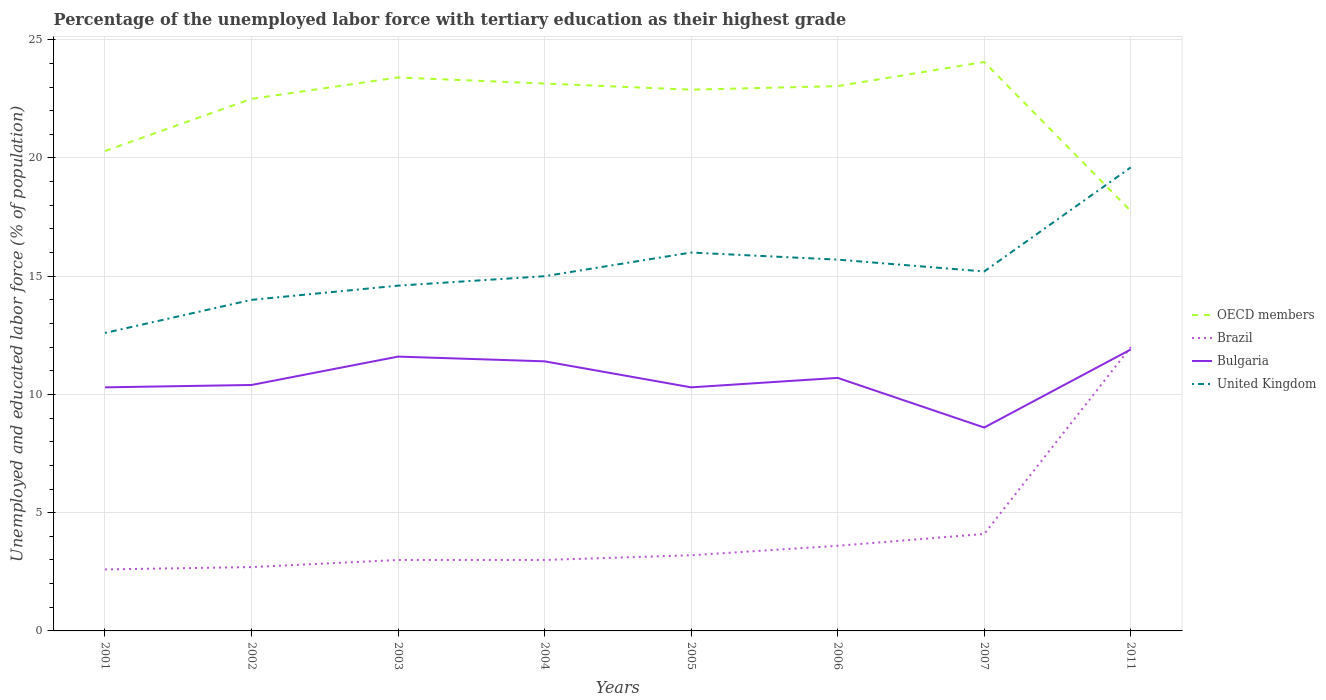How many different coloured lines are there?
Provide a succinct answer. 4. Does the line corresponding to United Kingdom intersect with the line corresponding to Brazil?
Your answer should be very brief. No. Is the number of lines equal to the number of legend labels?
Ensure brevity in your answer.  Yes. Across all years, what is the maximum percentage of the unemployed labor force with tertiary education in United Kingdom?
Your answer should be very brief. 12.6. In which year was the percentage of the unemployed labor force with tertiary education in Bulgaria maximum?
Give a very brief answer. 2007. What is the total percentage of the unemployed labor force with tertiary education in United Kingdom in the graph?
Make the answer very short. -3.4. What is the difference between the highest and the second highest percentage of the unemployed labor force with tertiary education in Brazil?
Offer a very short reply. 9.4. What is the difference between the highest and the lowest percentage of the unemployed labor force with tertiary education in Bulgaria?
Offer a terse response. 4. Does the graph contain any zero values?
Provide a succinct answer. No. Does the graph contain grids?
Provide a short and direct response. Yes. Where does the legend appear in the graph?
Ensure brevity in your answer.  Center right. How many legend labels are there?
Provide a short and direct response. 4. What is the title of the graph?
Provide a short and direct response. Percentage of the unemployed labor force with tertiary education as their highest grade. What is the label or title of the Y-axis?
Make the answer very short. Unemployed and educated labor force (% of population). What is the Unemployed and educated labor force (% of population) of OECD members in 2001?
Your answer should be very brief. 20.29. What is the Unemployed and educated labor force (% of population) in Brazil in 2001?
Provide a succinct answer. 2.6. What is the Unemployed and educated labor force (% of population) in Bulgaria in 2001?
Offer a very short reply. 10.3. What is the Unemployed and educated labor force (% of population) of United Kingdom in 2001?
Your answer should be compact. 12.6. What is the Unemployed and educated labor force (% of population) of OECD members in 2002?
Your response must be concise. 22.5. What is the Unemployed and educated labor force (% of population) in Brazil in 2002?
Offer a terse response. 2.7. What is the Unemployed and educated labor force (% of population) of Bulgaria in 2002?
Offer a very short reply. 10.4. What is the Unemployed and educated labor force (% of population) of OECD members in 2003?
Offer a very short reply. 23.4. What is the Unemployed and educated labor force (% of population) in Brazil in 2003?
Keep it short and to the point. 3. What is the Unemployed and educated labor force (% of population) of Bulgaria in 2003?
Provide a succinct answer. 11.6. What is the Unemployed and educated labor force (% of population) in United Kingdom in 2003?
Your response must be concise. 14.6. What is the Unemployed and educated labor force (% of population) of OECD members in 2004?
Keep it short and to the point. 23.15. What is the Unemployed and educated labor force (% of population) of Brazil in 2004?
Offer a terse response. 3. What is the Unemployed and educated labor force (% of population) in Bulgaria in 2004?
Provide a short and direct response. 11.4. What is the Unemployed and educated labor force (% of population) of OECD members in 2005?
Your answer should be very brief. 22.89. What is the Unemployed and educated labor force (% of population) in Brazil in 2005?
Ensure brevity in your answer.  3.2. What is the Unemployed and educated labor force (% of population) of Bulgaria in 2005?
Give a very brief answer. 10.3. What is the Unemployed and educated labor force (% of population) in United Kingdom in 2005?
Offer a very short reply. 16. What is the Unemployed and educated labor force (% of population) in OECD members in 2006?
Offer a very short reply. 23.04. What is the Unemployed and educated labor force (% of population) of Brazil in 2006?
Your answer should be very brief. 3.6. What is the Unemployed and educated labor force (% of population) of Bulgaria in 2006?
Provide a succinct answer. 10.7. What is the Unemployed and educated labor force (% of population) of United Kingdom in 2006?
Provide a short and direct response. 15.7. What is the Unemployed and educated labor force (% of population) in OECD members in 2007?
Give a very brief answer. 24.06. What is the Unemployed and educated labor force (% of population) in Brazil in 2007?
Your response must be concise. 4.1. What is the Unemployed and educated labor force (% of population) of Bulgaria in 2007?
Ensure brevity in your answer.  8.6. What is the Unemployed and educated labor force (% of population) of United Kingdom in 2007?
Offer a very short reply. 15.2. What is the Unemployed and educated labor force (% of population) in OECD members in 2011?
Provide a short and direct response. 17.76. What is the Unemployed and educated labor force (% of population) of Bulgaria in 2011?
Give a very brief answer. 11.9. What is the Unemployed and educated labor force (% of population) of United Kingdom in 2011?
Keep it short and to the point. 19.6. Across all years, what is the maximum Unemployed and educated labor force (% of population) in OECD members?
Offer a very short reply. 24.06. Across all years, what is the maximum Unemployed and educated labor force (% of population) of Brazil?
Keep it short and to the point. 12. Across all years, what is the maximum Unemployed and educated labor force (% of population) in Bulgaria?
Make the answer very short. 11.9. Across all years, what is the maximum Unemployed and educated labor force (% of population) in United Kingdom?
Your answer should be very brief. 19.6. Across all years, what is the minimum Unemployed and educated labor force (% of population) in OECD members?
Give a very brief answer. 17.76. Across all years, what is the minimum Unemployed and educated labor force (% of population) in Brazil?
Your answer should be compact. 2.6. Across all years, what is the minimum Unemployed and educated labor force (% of population) in Bulgaria?
Offer a very short reply. 8.6. Across all years, what is the minimum Unemployed and educated labor force (% of population) of United Kingdom?
Your answer should be very brief. 12.6. What is the total Unemployed and educated labor force (% of population) in OECD members in the graph?
Keep it short and to the point. 177.09. What is the total Unemployed and educated labor force (% of population) of Brazil in the graph?
Offer a terse response. 34.2. What is the total Unemployed and educated labor force (% of population) in Bulgaria in the graph?
Provide a succinct answer. 85.2. What is the total Unemployed and educated labor force (% of population) in United Kingdom in the graph?
Your answer should be compact. 122.7. What is the difference between the Unemployed and educated labor force (% of population) of OECD members in 2001 and that in 2002?
Offer a terse response. -2.2. What is the difference between the Unemployed and educated labor force (% of population) in Brazil in 2001 and that in 2002?
Make the answer very short. -0.1. What is the difference between the Unemployed and educated labor force (% of population) of OECD members in 2001 and that in 2003?
Your response must be concise. -3.11. What is the difference between the Unemployed and educated labor force (% of population) in Bulgaria in 2001 and that in 2003?
Ensure brevity in your answer.  -1.3. What is the difference between the Unemployed and educated labor force (% of population) in United Kingdom in 2001 and that in 2003?
Ensure brevity in your answer.  -2. What is the difference between the Unemployed and educated labor force (% of population) of OECD members in 2001 and that in 2004?
Provide a short and direct response. -2.85. What is the difference between the Unemployed and educated labor force (% of population) of Brazil in 2001 and that in 2004?
Give a very brief answer. -0.4. What is the difference between the Unemployed and educated labor force (% of population) of Bulgaria in 2001 and that in 2004?
Ensure brevity in your answer.  -1.1. What is the difference between the Unemployed and educated labor force (% of population) in United Kingdom in 2001 and that in 2004?
Make the answer very short. -2.4. What is the difference between the Unemployed and educated labor force (% of population) of OECD members in 2001 and that in 2005?
Your answer should be compact. -2.59. What is the difference between the Unemployed and educated labor force (% of population) of United Kingdom in 2001 and that in 2005?
Your answer should be compact. -3.4. What is the difference between the Unemployed and educated labor force (% of population) of OECD members in 2001 and that in 2006?
Ensure brevity in your answer.  -2.74. What is the difference between the Unemployed and educated labor force (% of population) of Brazil in 2001 and that in 2006?
Provide a short and direct response. -1. What is the difference between the Unemployed and educated labor force (% of population) of OECD members in 2001 and that in 2007?
Give a very brief answer. -3.77. What is the difference between the Unemployed and educated labor force (% of population) of Bulgaria in 2001 and that in 2007?
Provide a succinct answer. 1.7. What is the difference between the Unemployed and educated labor force (% of population) of OECD members in 2001 and that in 2011?
Provide a succinct answer. 2.54. What is the difference between the Unemployed and educated labor force (% of population) of Brazil in 2001 and that in 2011?
Give a very brief answer. -9.4. What is the difference between the Unemployed and educated labor force (% of population) of Bulgaria in 2001 and that in 2011?
Ensure brevity in your answer.  -1.6. What is the difference between the Unemployed and educated labor force (% of population) of United Kingdom in 2001 and that in 2011?
Offer a terse response. -7. What is the difference between the Unemployed and educated labor force (% of population) of OECD members in 2002 and that in 2003?
Keep it short and to the point. -0.91. What is the difference between the Unemployed and educated labor force (% of population) of Bulgaria in 2002 and that in 2003?
Give a very brief answer. -1.2. What is the difference between the Unemployed and educated labor force (% of population) of OECD members in 2002 and that in 2004?
Your answer should be very brief. -0.65. What is the difference between the Unemployed and educated labor force (% of population) of Brazil in 2002 and that in 2004?
Keep it short and to the point. -0.3. What is the difference between the Unemployed and educated labor force (% of population) in Bulgaria in 2002 and that in 2004?
Your answer should be very brief. -1. What is the difference between the Unemployed and educated labor force (% of population) in OECD members in 2002 and that in 2005?
Keep it short and to the point. -0.39. What is the difference between the Unemployed and educated labor force (% of population) in Brazil in 2002 and that in 2005?
Your response must be concise. -0.5. What is the difference between the Unemployed and educated labor force (% of population) in Bulgaria in 2002 and that in 2005?
Offer a terse response. 0.1. What is the difference between the Unemployed and educated labor force (% of population) in United Kingdom in 2002 and that in 2005?
Your answer should be compact. -2. What is the difference between the Unemployed and educated labor force (% of population) of OECD members in 2002 and that in 2006?
Ensure brevity in your answer.  -0.54. What is the difference between the Unemployed and educated labor force (% of population) in Bulgaria in 2002 and that in 2006?
Your response must be concise. -0.3. What is the difference between the Unemployed and educated labor force (% of population) in OECD members in 2002 and that in 2007?
Offer a very short reply. -1.56. What is the difference between the Unemployed and educated labor force (% of population) of Brazil in 2002 and that in 2007?
Your response must be concise. -1.4. What is the difference between the Unemployed and educated labor force (% of population) in United Kingdom in 2002 and that in 2007?
Give a very brief answer. -1.2. What is the difference between the Unemployed and educated labor force (% of population) in OECD members in 2002 and that in 2011?
Keep it short and to the point. 4.74. What is the difference between the Unemployed and educated labor force (% of population) in Bulgaria in 2002 and that in 2011?
Your response must be concise. -1.5. What is the difference between the Unemployed and educated labor force (% of population) in OECD members in 2003 and that in 2004?
Your answer should be compact. 0.26. What is the difference between the Unemployed and educated labor force (% of population) of Brazil in 2003 and that in 2004?
Keep it short and to the point. 0. What is the difference between the Unemployed and educated labor force (% of population) in Bulgaria in 2003 and that in 2004?
Ensure brevity in your answer.  0.2. What is the difference between the Unemployed and educated labor force (% of population) in OECD members in 2003 and that in 2005?
Your answer should be compact. 0.52. What is the difference between the Unemployed and educated labor force (% of population) in OECD members in 2003 and that in 2006?
Keep it short and to the point. 0.37. What is the difference between the Unemployed and educated labor force (% of population) of Brazil in 2003 and that in 2006?
Make the answer very short. -0.6. What is the difference between the Unemployed and educated labor force (% of population) in Bulgaria in 2003 and that in 2006?
Your answer should be very brief. 0.9. What is the difference between the Unemployed and educated labor force (% of population) in OECD members in 2003 and that in 2007?
Keep it short and to the point. -0.66. What is the difference between the Unemployed and educated labor force (% of population) of Brazil in 2003 and that in 2007?
Ensure brevity in your answer.  -1.1. What is the difference between the Unemployed and educated labor force (% of population) of United Kingdom in 2003 and that in 2007?
Offer a very short reply. -0.6. What is the difference between the Unemployed and educated labor force (% of population) in OECD members in 2003 and that in 2011?
Offer a very short reply. 5.65. What is the difference between the Unemployed and educated labor force (% of population) in Bulgaria in 2003 and that in 2011?
Give a very brief answer. -0.3. What is the difference between the Unemployed and educated labor force (% of population) in United Kingdom in 2003 and that in 2011?
Provide a short and direct response. -5. What is the difference between the Unemployed and educated labor force (% of population) in OECD members in 2004 and that in 2005?
Provide a short and direct response. 0.26. What is the difference between the Unemployed and educated labor force (% of population) of United Kingdom in 2004 and that in 2005?
Provide a short and direct response. -1. What is the difference between the Unemployed and educated labor force (% of population) in OECD members in 2004 and that in 2006?
Offer a very short reply. 0.11. What is the difference between the Unemployed and educated labor force (% of population) of OECD members in 2004 and that in 2007?
Keep it short and to the point. -0.91. What is the difference between the Unemployed and educated labor force (% of population) in Brazil in 2004 and that in 2007?
Offer a terse response. -1.1. What is the difference between the Unemployed and educated labor force (% of population) in OECD members in 2004 and that in 2011?
Your response must be concise. 5.39. What is the difference between the Unemployed and educated labor force (% of population) in Bulgaria in 2004 and that in 2011?
Provide a succinct answer. -0.5. What is the difference between the Unemployed and educated labor force (% of population) of United Kingdom in 2004 and that in 2011?
Provide a succinct answer. -4.6. What is the difference between the Unemployed and educated labor force (% of population) in OECD members in 2005 and that in 2006?
Provide a short and direct response. -0.15. What is the difference between the Unemployed and educated labor force (% of population) in Brazil in 2005 and that in 2006?
Ensure brevity in your answer.  -0.4. What is the difference between the Unemployed and educated labor force (% of population) of OECD members in 2005 and that in 2007?
Keep it short and to the point. -1.17. What is the difference between the Unemployed and educated labor force (% of population) of United Kingdom in 2005 and that in 2007?
Provide a short and direct response. 0.8. What is the difference between the Unemployed and educated labor force (% of population) in OECD members in 2005 and that in 2011?
Your answer should be compact. 5.13. What is the difference between the Unemployed and educated labor force (% of population) in Bulgaria in 2005 and that in 2011?
Provide a short and direct response. -1.6. What is the difference between the Unemployed and educated labor force (% of population) of United Kingdom in 2005 and that in 2011?
Your response must be concise. -3.6. What is the difference between the Unemployed and educated labor force (% of population) in OECD members in 2006 and that in 2007?
Offer a very short reply. -1.02. What is the difference between the Unemployed and educated labor force (% of population) in OECD members in 2006 and that in 2011?
Offer a very short reply. 5.28. What is the difference between the Unemployed and educated labor force (% of population) of Bulgaria in 2006 and that in 2011?
Offer a very short reply. -1.2. What is the difference between the Unemployed and educated labor force (% of population) of United Kingdom in 2006 and that in 2011?
Provide a short and direct response. -3.9. What is the difference between the Unemployed and educated labor force (% of population) in OECD members in 2007 and that in 2011?
Offer a terse response. 6.3. What is the difference between the Unemployed and educated labor force (% of population) in Bulgaria in 2007 and that in 2011?
Provide a succinct answer. -3.3. What is the difference between the Unemployed and educated labor force (% of population) in United Kingdom in 2007 and that in 2011?
Make the answer very short. -4.4. What is the difference between the Unemployed and educated labor force (% of population) in OECD members in 2001 and the Unemployed and educated labor force (% of population) in Brazil in 2002?
Give a very brief answer. 17.59. What is the difference between the Unemployed and educated labor force (% of population) in OECD members in 2001 and the Unemployed and educated labor force (% of population) in Bulgaria in 2002?
Your answer should be very brief. 9.89. What is the difference between the Unemployed and educated labor force (% of population) of OECD members in 2001 and the Unemployed and educated labor force (% of population) of United Kingdom in 2002?
Offer a very short reply. 6.29. What is the difference between the Unemployed and educated labor force (% of population) in Brazil in 2001 and the Unemployed and educated labor force (% of population) in Bulgaria in 2002?
Provide a short and direct response. -7.8. What is the difference between the Unemployed and educated labor force (% of population) in OECD members in 2001 and the Unemployed and educated labor force (% of population) in Brazil in 2003?
Keep it short and to the point. 17.29. What is the difference between the Unemployed and educated labor force (% of population) of OECD members in 2001 and the Unemployed and educated labor force (% of population) of Bulgaria in 2003?
Give a very brief answer. 8.69. What is the difference between the Unemployed and educated labor force (% of population) in OECD members in 2001 and the Unemployed and educated labor force (% of population) in United Kingdom in 2003?
Your answer should be very brief. 5.69. What is the difference between the Unemployed and educated labor force (% of population) of Brazil in 2001 and the Unemployed and educated labor force (% of population) of Bulgaria in 2003?
Your answer should be very brief. -9. What is the difference between the Unemployed and educated labor force (% of population) of Brazil in 2001 and the Unemployed and educated labor force (% of population) of United Kingdom in 2003?
Offer a terse response. -12. What is the difference between the Unemployed and educated labor force (% of population) in OECD members in 2001 and the Unemployed and educated labor force (% of population) in Brazil in 2004?
Provide a short and direct response. 17.29. What is the difference between the Unemployed and educated labor force (% of population) of OECD members in 2001 and the Unemployed and educated labor force (% of population) of Bulgaria in 2004?
Offer a terse response. 8.89. What is the difference between the Unemployed and educated labor force (% of population) in OECD members in 2001 and the Unemployed and educated labor force (% of population) in United Kingdom in 2004?
Provide a succinct answer. 5.29. What is the difference between the Unemployed and educated labor force (% of population) in OECD members in 2001 and the Unemployed and educated labor force (% of population) in Brazil in 2005?
Offer a very short reply. 17.09. What is the difference between the Unemployed and educated labor force (% of population) in OECD members in 2001 and the Unemployed and educated labor force (% of population) in Bulgaria in 2005?
Offer a terse response. 9.99. What is the difference between the Unemployed and educated labor force (% of population) of OECD members in 2001 and the Unemployed and educated labor force (% of population) of United Kingdom in 2005?
Provide a succinct answer. 4.29. What is the difference between the Unemployed and educated labor force (% of population) of Bulgaria in 2001 and the Unemployed and educated labor force (% of population) of United Kingdom in 2005?
Provide a succinct answer. -5.7. What is the difference between the Unemployed and educated labor force (% of population) in OECD members in 2001 and the Unemployed and educated labor force (% of population) in Brazil in 2006?
Give a very brief answer. 16.69. What is the difference between the Unemployed and educated labor force (% of population) of OECD members in 2001 and the Unemployed and educated labor force (% of population) of Bulgaria in 2006?
Offer a terse response. 9.59. What is the difference between the Unemployed and educated labor force (% of population) in OECD members in 2001 and the Unemployed and educated labor force (% of population) in United Kingdom in 2006?
Give a very brief answer. 4.59. What is the difference between the Unemployed and educated labor force (% of population) of Bulgaria in 2001 and the Unemployed and educated labor force (% of population) of United Kingdom in 2006?
Your answer should be very brief. -5.4. What is the difference between the Unemployed and educated labor force (% of population) of OECD members in 2001 and the Unemployed and educated labor force (% of population) of Brazil in 2007?
Your answer should be very brief. 16.19. What is the difference between the Unemployed and educated labor force (% of population) of OECD members in 2001 and the Unemployed and educated labor force (% of population) of Bulgaria in 2007?
Provide a succinct answer. 11.69. What is the difference between the Unemployed and educated labor force (% of population) of OECD members in 2001 and the Unemployed and educated labor force (% of population) of United Kingdom in 2007?
Your answer should be compact. 5.09. What is the difference between the Unemployed and educated labor force (% of population) of Brazil in 2001 and the Unemployed and educated labor force (% of population) of United Kingdom in 2007?
Your response must be concise. -12.6. What is the difference between the Unemployed and educated labor force (% of population) in OECD members in 2001 and the Unemployed and educated labor force (% of population) in Brazil in 2011?
Offer a terse response. 8.29. What is the difference between the Unemployed and educated labor force (% of population) in OECD members in 2001 and the Unemployed and educated labor force (% of population) in Bulgaria in 2011?
Offer a very short reply. 8.39. What is the difference between the Unemployed and educated labor force (% of population) of OECD members in 2001 and the Unemployed and educated labor force (% of population) of United Kingdom in 2011?
Ensure brevity in your answer.  0.69. What is the difference between the Unemployed and educated labor force (% of population) of Brazil in 2001 and the Unemployed and educated labor force (% of population) of Bulgaria in 2011?
Your answer should be compact. -9.3. What is the difference between the Unemployed and educated labor force (% of population) in Brazil in 2001 and the Unemployed and educated labor force (% of population) in United Kingdom in 2011?
Your answer should be very brief. -17. What is the difference between the Unemployed and educated labor force (% of population) in OECD members in 2002 and the Unemployed and educated labor force (% of population) in Brazil in 2003?
Your response must be concise. 19.5. What is the difference between the Unemployed and educated labor force (% of population) of OECD members in 2002 and the Unemployed and educated labor force (% of population) of Bulgaria in 2003?
Ensure brevity in your answer.  10.9. What is the difference between the Unemployed and educated labor force (% of population) of OECD members in 2002 and the Unemployed and educated labor force (% of population) of United Kingdom in 2003?
Provide a succinct answer. 7.9. What is the difference between the Unemployed and educated labor force (% of population) in Brazil in 2002 and the Unemployed and educated labor force (% of population) in Bulgaria in 2003?
Offer a very short reply. -8.9. What is the difference between the Unemployed and educated labor force (% of population) in Brazil in 2002 and the Unemployed and educated labor force (% of population) in United Kingdom in 2003?
Give a very brief answer. -11.9. What is the difference between the Unemployed and educated labor force (% of population) in Bulgaria in 2002 and the Unemployed and educated labor force (% of population) in United Kingdom in 2003?
Keep it short and to the point. -4.2. What is the difference between the Unemployed and educated labor force (% of population) in OECD members in 2002 and the Unemployed and educated labor force (% of population) in Brazil in 2004?
Your answer should be compact. 19.5. What is the difference between the Unemployed and educated labor force (% of population) in OECD members in 2002 and the Unemployed and educated labor force (% of population) in Bulgaria in 2004?
Ensure brevity in your answer.  11.1. What is the difference between the Unemployed and educated labor force (% of population) of OECD members in 2002 and the Unemployed and educated labor force (% of population) of United Kingdom in 2004?
Keep it short and to the point. 7.5. What is the difference between the Unemployed and educated labor force (% of population) in Brazil in 2002 and the Unemployed and educated labor force (% of population) in United Kingdom in 2004?
Your answer should be very brief. -12.3. What is the difference between the Unemployed and educated labor force (% of population) of Bulgaria in 2002 and the Unemployed and educated labor force (% of population) of United Kingdom in 2004?
Offer a terse response. -4.6. What is the difference between the Unemployed and educated labor force (% of population) of OECD members in 2002 and the Unemployed and educated labor force (% of population) of Brazil in 2005?
Offer a terse response. 19.3. What is the difference between the Unemployed and educated labor force (% of population) of OECD members in 2002 and the Unemployed and educated labor force (% of population) of Bulgaria in 2005?
Offer a terse response. 12.2. What is the difference between the Unemployed and educated labor force (% of population) in OECD members in 2002 and the Unemployed and educated labor force (% of population) in United Kingdom in 2005?
Your answer should be very brief. 6.5. What is the difference between the Unemployed and educated labor force (% of population) in Brazil in 2002 and the Unemployed and educated labor force (% of population) in Bulgaria in 2005?
Your response must be concise. -7.6. What is the difference between the Unemployed and educated labor force (% of population) of Bulgaria in 2002 and the Unemployed and educated labor force (% of population) of United Kingdom in 2005?
Your answer should be compact. -5.6. What is the difference between the Unemployed and educated labor force (% of population) of OECD members in 2002 and the Unemployed and educated labor force (% of population) of Brazil in 2006?
Your answer should be compact. 18.9. What is the difference between the Unemployed and educated labor force (% of population) in OECD members in 2002 and the Unemployed and educated labor force (% of population) in Bulgaria in 2006?
Offer a terse response. 11.8. What is the difference between the Unemployed and educated labor force (% of population) of OECD members in 2002 and the Unemployed and educated labor force (% of population) of United Kingdom in 2006?
Your answer should be compact. 6.8. What is the difference between the Unemployed and educated labor force (% of population) in Brazil in 2002 and the Unemployed and educated labor force (% of population) in Bulgaria in 2006?
Provide a short and direct response. -8. What is the difference between the Unemployed and educated labor force (% of population) of Brazil in 2002 and the Unemployed and educated labor force (% of population) of United Kingdom in 2006?
Give a very brief answer. -13. What is the difference between the Unemployed and educated labor force (% of population) of Bulgaria in 2002 and the Unemployed and educated labor force (% of population) of United Kingdom in 2006?
Offer a terse response. -5.3. What is the difference between the Unemployed and educated labor force (% of population) in OECD members in 2002 and the Unemployed and educated labor force (% of population) in Brazil in 2007?
Make the answer very short. 18.4. What is the difference between the Unemployed and educated labor force (% of population) in OECD members in 2002 and the Unemployed and educated labor force (% of population) in Bulgaria in 2007?
Your answer should be compact. 13.9. What is the difference between the Unemployed and educated labor force (% of population) of OECD members in 2002 and the Unemployed and educated labor force (% of population) of United Kingdom in 2007?
Your answer should be very brief. 7.3. What is the difference between the Unemployed and educated labor force (% of population) of Brazil in 2002 and the Unemployed and educated labor force (% of population) of United Kingdom in 2007?
Your answer should be compact. -12.5. What is the difference between the Unemployed and educated labor force (% of population) of Bulgaria in 2002 and the Unemployed and educated labor force (% of population) of United Kingdom in 2007?
Keep it short and to the point. -4.8. What is the difference between the Unemployed and educated labor force (% of population) in OECD members in 2002 and the Unemployed and educated labor force (% of population) in Brazil in 2011?
Offer a very short reply. 10.5. What is the difference between the Unemployed and educated labor force (% of population) of OECD members in 2002 and the Unemployed and educated labor force (% of population) of Bulgaria in 2011?
Your response must be concise. 10.6. What is the difference between the Unemployed and educated labor force (% of population) of OECD members in 2002 and the Unemployed and educated labor force (% of population) of United Kingdom in 2011?
Provide a succinct answer. 2.9. What is the difference between the Unemployed and educated labor force (% of population) in Brazil in 2002 and the Unemployed and educated labor force (% of population) in Bulgaria in 2011?
Your answer should be very brief. -9.2. What is the difference between the Unemployed and educated labor force (% of population) of Brazil in 2002 and the Unemployed and educated labor force (% of population) of United Kingdom in 2011?
Keep it short and to the point. -16.9. What is the difference between the Unemployed and educated labor force (% of population) of Bulgaria in 2002 and the Unemployed and educated labor force (% of population) of United Kingdom in 2011?
Provide a short and direct response. -9.2. What is the difference between the Unemployed and educated labor force (% of population) of OECD members in 2003 and the Unemployed and educated labor force (% of population) of Brazil in 2004?
Give a very brief answer. 20.4. What is the difference between the Unemployed and educated labor force (% of population) in OECD members in 2003 and the Unemployed and educated labor force (% of population) in Bulgaria in 2004?
Offer a very short reply. 12. What is the difference between the Unemployed and educated labor force (% of population) of OECD members in 2003 and the Unemployed and educated labor force (% of population) of United Kingdom in 2004?
Ensure brevity in your answer.  8.4. What is the difference between the Unemployed and educated labor force (% of population) of Brazil in 2003 and the Unemployed and educated labor force (% of population) of Bulgaria in 2004?
Keep it short and to the point. -8.4. What is the difference between the Unemployed and educated labor force (% of population) in OECD members in 2003 and the Unemployed and educated labor force (% of population) in Brazil in 2005?
Give a very brief answer. 20.2. What is the difference between the Unemployed and educated labor force (% of population) of OECD members in 2003 and the Unemployed and educated labor force (% of population) of Bulgaria in 2005?
Your answer should be compact. 13.1. What is the difference between the Unemployed and educated labor force (% of population) in OECD members in 2003 and the Unemployed and educated labor force (% of population) in United Kingdom in 2005?
Offer a very short reply. 7.4. What is the difference between the Unemployed and educated labor force (% of population) in Brazil in 2003 and the Unemployed and educated labor force (% of population) in Bulgaria in 2005?
Make the answer very short. -7.3. What is the difference between the Unemployed and educated labor force (% of population) of Brazil in 2003 and the Unemployed and educated labor force (% of population) of United Kingdom in 2005?
Ensure brevity in your answer.  -13. What is the difference between the Unemployed and educated labor force (% of population) in OECD members in 2003 and the Unemployed and educated labor force (% of population) in Brazil in 2006?
Keep it short and to the point. 19.8. What is the difference between the Unemployed and educated labor force (% of population) of OECD members in 2003 and the Unemployed and educated labor force (% of population) of Bulgaria in 2006?
Your answer should be compact. 12.7. What is the difference between the Unemployed and educated labor force (% of population) of OECD members in 2003 and the Unemployed and educated labor force (% of population) of United Kingdom in 2006?
Give a very brief answer. 7.7. What is the difference between the Unemployed and educated labor force (% of population) of Brazil in 2003 and the Unemployed and educated labor force (% of population) of Bulgaria in 2006?
Make the answer very short. -7.7. What is the difference between the Unemployed and educated labor force (% of population) of OECD members in 2003 and the Unemployed and educated labor force (% of population) of Brazil in 2007?
Provide a succinct answer. 19.3. What is the difference between the Unemployed and educated labor force (% of population) in OECD members in 2003 and the Unemployed and educated labor force (% of population) in Bulgaria in 2007?
Your response must be concise. 14.8. What is the difference between the Unemployed and educated labor force (% of population) of OECD members in 2003 and the Unemployed and educated labor force (% of population) of United Kingdom in 2007?
Offer a very short reply. 8.2. What is the difference between the Unemployed and educated labor force (% of population) of Brazil in 2003 and the Unemployed and educated labor force (% of population) of Bulgaria in 2007?
Your response must be concise. -5.6. What is the difference between the Unemployed and educated labor force (% of population) of Bulgaria in 2003 and the Unemployed and educated labor force (% of population) of United Kingdom in 2007?
Your answer should be compact. -3.6. What is the difference between the Unemployed and educated labor force (% of population) in OECD members in 2003 and the Unemployed and educated labor force (% of population) in Brazil in 2011?
Keep it short and to the point. 11.4. What is the difference between the Unemployed and educated labor force (% of population) in OECD members in 2003 and the Unemployed and educated labor force (% of population) in Bulgaria in 2011?
Ensure brevity in your answer.  11.5. What is the difference between the Unemployed and educated labor force (% of population) in OECD members in 2003 and the Unemployed and educated labor force (% of population) in United Kingdom in 2011?
Offer a very short reply. 3.8. What is the difference between the Unemployed and educated labor force (% of population) of Brazil in 2003 and the Unemployed and educated labor force (% of population) of Bulgaria in 2011?
Provide a short and direct response. -8.9. What is the difference between the Unemployed and educated labor force (% of population) of Brazil in 2003 and the Unemployed and educated labor force (% of population) of United Kingdom in 2011?
Your answer should be compact. -16.6. What is the difference between the Unemployed and educated labor force (% of population) in Bulgaria in 2003 and the Unemployed and educated labor force (% of population) in United Kingdom in 2011?
Offer a very short reply. -8. What is the difference between the Unemployed and educated labor force (% of population) in OECD members in 2004 and the Unemployed and educated labor force (% of population) in Brazil in 2005?
Give a very brief answer. 19.95. What is the difference between the Unemployed and educated labor force (% of population) of OECD members in 2004 and the Unemployed and educated labor force (% of population) of Bulgaria in 2005?
Offer a terse response. 12.85. What is the difference between the Unemployed and educated labor force (% of population) of OECD members in 2004 and the Unemployed and educated labor force (% of population) of United Kingdom in 2005?
Provide a succinct answer. 7.15. What is the difference between the Unemployed and educated labor force (% of population) of Brazil in 2004 and the Unemployed and educated labor force (% of population) of Bulgaria in 2005?
Ensure brevity in your answer.  -7.3. What is the difference between the Unemployed and educated labor force (% of population) of OECD members in 2004 and the Unemployed and educated labor force (% of population) of Brazil in 2006?
Give a very brief answer. 19.55. What is the difference between the Unemployed and educated labor force (% of population) in OECD members in 2004 and the Unemployed and educated labor force (% of population) in Bulgaria in 2006?
Your response must be concise. 12.45. What is the difference between the Unemployed and educated labor force (% of population) in OECD members in 2004 and the Unemployed and educated labor force (% of population) in United Kingdom in 2006?
Offer a terse response. 7.45. What is the difference between the Unemployed and educated labor force (% of population) of Brazil in 2004 and the Unemployed and educated labor force (% of population) of Bulgaria in 2006?
Keep it short and to the point. -7.7. What is the difference between the Unemployed and educated labor force (% of population) in Bulgaria in 2004 and the Unemployed and educated labor force (% of population) in United Kingdom in 2006?
Keep it short and to the point. -4.3. What is the difference between the Unemployed and educated labor force (% of population) of OECD members in 2004 and the Unemployed and educated labor force (% of population) of Brazil in 2007?
Give a very brief answer. 19.05. What is the difference between the Unemployed and educated labor force (% of population) in OECD members in 2004 and the Unemployed and educated labor force (% of population) in Bulgaria in 2007?
Your answer should be compact. 14.55. What is the difference between the Unemployed and educated labor force (% of population) in OECD members in 2004 and the Unemployed and educated labor force (% of population) in United Kingdom in 2007?
Ensure brevity in your answer.  7.95. What is the difference between the Unemployed and educated labor force (% of population) of OECD members in 2004 and the Unemployed and educated labor force (% of population) of Brazil in 2011?
Offer a very short reply. 11.15. What is the difference between the Unemployed and educated labor force (% of population) in OECD members in 2004 and the Unemployed and educated labor force (% of population) in Bulgaria in 2011?
Offer a terse response. 11.25. What is the difference between the Unemployed and educated labor force (% of population) of OECD members in 2004 and the Unemployed and educated labor force (% of population) of United Kingdom in 2011?
Ensure brevity in your answer.  3.55. What is the difference between the Unemployed and educated labor force (% of population) in Brazil in 2004 and the Unemployed and educated labor force (% of population) in United Kingdom in 2011?
Provide a succinct answer. -16.6. What is the difference between the Unemployed and educated labor force (% of population) in OECD members in 2005 and the Unemployed and educated labor force (% of population) in Brazil in 2006?
Keep it short and to the point. 19.29. What is the difference between the Unemployed and educated labor force (% of population) of OECD members in 2005 and the Unemployed and educated labor force (% of population) of Bulgaria in 2006?
Your answer should be very brief. 12.19. What is the difference between the Unemployed and educated labor force (% of population) in OECD members in 2005 and the Unemployed and educated labor force (% of population) in United Kingdom in 2006?
Your response must be concise. 7.19. What is the difference between the Unemployed and educated labor force (% of population) of Bulgaria in 2005 and the Unemployed and educated labor force (% of population) of United Kingdom in 2006?
Make the answer very short. -5.4. What is the difference between the Unemployed and educated labor force (% of population) in OECD members in 2005 and the Unemployed and educated labor force (% of population) in Brazil in 2007?
Provide a succinct answer. 18.79. What is the difference between the Unemployed and educated labor force (% of population) in OECD members in 2005 and the Unemployed and educated labor force (% of population) in Bulgaria in 2007?
Make the answer very short. 14.29. What is the difference between the Unemployed and educated labor force (% of population) of OECD members in 2005 and the Unemployed and educated labor force (% of population) of United Kingdom in 2007?
Your response must be concise. 7.69. What is the difference between the Unemployed and educated labor force (% of population) in Brazil in 2005 and the Unemployed and educated labor force (% of population) in Bulgaria in 2007?
Offer a very short reply. -5.4. What is the difference between the Unemployed and educated labor force (% of population) of OECD members in 2005 and the Unemployed and educated labor force (% of population) of Brazil in 2011?
Your response must be concise. 10.89. What is the difference between the Unemployed and educated labor force (% of population) of OECD members in 2005 and the Unemployed and educated labor force (% of population) of Bulgaria in 2011?
Offer a terse response. 10.99. What is the difference between the Unemployed and educated labor force (% of population) in OECD members in 2005 and the Unemployed and educated labor force (% of population) in United Kingdom in 2011?
Give a very brief answer. 3.29. What is the difference between the Unemployed and educated labor force (% of population) of Brazil in 2005 and the Unemployed and educated labor force (% of population) of Bulgaria in 2011?
Your answer should be compact. -8.7. What is the difference between the Unemployed and educated labor force (% of population) of Brazil in 2005 and the Unemployed and educated labor force (% of population) of United Kingdom in 2011?
Offer a terse response. -16.4. What is the difference between the Unemployed and educated labor force (% of population) of Bulgaria in 2005 and the Unemployed and educated labor force (% of population) of United Kingdom in 2011?
Your answer should be compact. -9.3. What is the difference between the Unemployed and educated labor force (% of population) in OECD members in 2006 and the Unemployed and educated labor force (% of population) in Brazil in 2007?
Offer a very short reply. 18.94. What is the difference between the Unemployed and educated labor force (% of population) in OECD members in 2006 and the Unemployed and educated labor force (% of population) in Bulgaria in 2007?
Provide a short and direct response. 14.44. What is the difference between the Unemployed and educated labor force (% of population) in OECD members in 2006 and the Unemployed and educated labor force (% of population) in United Kingdom in 2007?
Make the answer very short. 7.84. What is the difference between the Unemployed and educated labor force (% of population) in OECD members in 2006 and the Unemployed and educated labor force (% of population) in Brazil in 2011?
Your response must be concise. 11.04. What is the difference between the Unemployed and educated labor force (% of population) of OECD members in 2006 and the Unemployed and educated labor force (% of population) of Bulgaria in 2011?
Make the answer very short. 11.14. What is the difference between the Unemployed and educated labor force (% of population) in OECD members in 2006 and the Unemployed and educated labor force (% of population) in United Kingdom in 2011?
Provide a short and direct response. 3.44. What is the difference between the Unemployed and educated labor force (% of population) in Bulgaria in 2006 and the Unemployed and educated labor force (% of population) in United Kingdom in 2011?
Provide a short and direct response. -8.9. What is the difference between the Unemployed and educated labor force (% of population) in OECD members in 2007 and the Unemployed and educated labor force (% of population) in Brazil in 2011?
Provide a short and direct response. 12.06. What is the difference between the Unemployed and educated labor force (% of population) of OECD members in 2007 and the Unemployed and educated labor force (% of population) of Bulgaria in 2011?
Your answer should be compact. 12.16. What is the difference between the Unemployed and educated labor force (% of population) in OECD members in 2007 and the Unemployed and educated labor force (% of population) in United Kingdom in 2011?
Your answer should be very brief. 4.46. What is the difference between the Unemployed and educated labor force (% of population) of Brazil in 2007 and the Unemployed and educated labor force (% of population) of United Kingdom in 2011?
Provide a short and direct response. -15.5. What is the difference between the Unemployed and educated labor force (% of population) of Bulgaria in 2007 and the Unemployed and educated labor force (% of population) of United Kingdom in 2011?
Offer a terse response. -11. What is the average Unemployed and educated labor force (% of population) in OECD members per year?
Your answer should be compact. 22.14. What is the average Unemployed and educated labor force (% of population) in Brazil per year?
Provide a short and direct response. 4.28. What is the average Unemployed and educated labor force (% of population) in Bulgaria per year?
Provide a short and direct response. 10.65. What is the average Unemployed and educated labor force (% of population) in United Kingdom per year?
Make the answer very short. 15.34. In the year 2001, what is the difference between the Unemployed and educated labor force (% of population) in OECD members and Unemployed and educated labor force (% of population) in Brazil?
Make the answer very short. 17.69. In the year 2001, what is the difference between the Unemployed and educated labor force (% of population) in OECD members and Unemployed and educated labor force (% of population) in Bulgaria?
Give a very brief answer. 9.99. In the year 2001, what is the difference between the Unemployed and educated labor force (% of population) in OECD members and Unemployed and educated labor force (% of population) in United Kingdom?
Give a very brief answer. 7.69. In the year 2001, what is the difference between the Unemployed and educated labor force (% of population) in Brazil and Unemployed and educated labor force (% of population) in Bulgaria?
Keep it short and to the point. -7.7. In the year 2001, what is the difference between the Unemployed and educated labor force (% of population) of Brazil and Unemployed and educated labor force (% of population) of United Kingdom?
Your response must be concise. -10. In the year 2002, what is the difference between the Unemployed and educated labor force (% of population) in OECD members and Unemployed and educated labor force (% of population) in Brazil?
Make the answer very short. 19.8. In the year 2002, what is the difference between the Unemployed and educated labor force (% of population) of OECD members and Unemployed and educated labor force (% of population) of Bulgaria?
Provide a succinct answer. 12.1. In the year 2002, what is the difference between the Unemployed and educated labor force (% of population) in OECD members and Unemployed and educated labor force (% of population) in United Kingdom?
Keep it short and to the point. 8.5. In the year 2002, what is the difference between the Unemployed and educated labor force (% of population) of Brazil and Unemployed and educated labor force (% of population) of United Kingdom?
Give a very brief answer. -11.3. In the year 2003, what is the difference between the Unemployed and educated labor force (% of population) in OECD members and Unemployed and educated labor force (% of population) in Brazil?
Provide a short and direct response. 20.4. In the year 2003, what is the difference between the Unemployed and educated labor force (% of population) of OECD members and Unemployed and educated labor force (% of population) of Bulgaria?
Offer a terse response. 11.8. In the year 2003, what is the difference between the Unemployed and educated labor force (% of population) in OECD members and Unemployed and educated labor force (% of population) in United Kingdom?
Ensure brevity in your answer.  8.8. In the year 2003, what is the difference between the Unemployed and educated labor force (% of population) in Brazil and Unemployed and educated labor force (% of population) in Bulgaria?
Provide a succinct answer. -8.6. In the year 2003, what is the difference between the Unemployed and educated labor force (% of population) of Bulgaria and Unemployed and educated labor force (% of population) of United Kingdom?
Provide a succinct answer. -3. In the year 2004, what is the difference between the Unemployed and educated labor force (% of population) of OECD members and Unemployed and educated labor force (% of population) of Brazil?
Your answer should be compact. 20.15. In the year 2004, what is the difference between the Unemployed and educated labor force (% of population) in OECD members and Unemployed and educated labor force (% of population) in Bulgaria?
Offer a very short reply. 11.75. In the year 2004, what is the difference between the Unemployed and educated labor force (% of population) of OECD members and Unemployed and educated labor force (% of population) of United Kingdom?
Your response must be concise. 8.15. In the year 2004, what is the difference between the Unemployed and educated labor force (% of population) in Brazil and Unemployed and educated labor force (% of population) in Bulgaria?
Keep it short and to the point. -8.4. In the year 2004, what is the difference between the Unemployed and educated labor force (% of population) of Brazil and Unemployed and educated labor force (% of population) of United Kingdom?
Provide a short and direct response. -12. In the year 2004, what is the difference between the Unemployed and educated labor force (% of population) in Bulgaria and Unemployed and educated labor force (% of population) in United Kingdom?
Your answer should be compact. -3.6. In the year 2005, what is the difference between the Unemployed and educated labor force (% of population) in OECD members and Unemployed and educated labor force (% of population) in Brazil?
Offer a terse response. 19.69. In the year 2005, what is the difference between the Unemployed and educated labor force (% of population) in OECD members and Unemployed and educated labor force (% of population) in Bulgaria?
Provide a succinct answer. 12.59. In the year 2005, what is the difference between the Unemployed and educated labor force (% of population) in OECD members and Unemployed and educated labor force (% of population) in United Kingdom?
Offer a very short reply. 6.89. In the year 2005, what is the difference between the Unemployed and educated labor force (% of population) in Brazil and Unemployed and educated labor force (% of population) in United Kingdom?
Your answer should be compact. -12.8. In the year 2005, what is the difference between the Unemployed and educated labor force (% of population) in Bulgaria and Unemployed and educated labor force (% of population) in United Kingdom?
Provide a short and direct response. -5.7. In the year 2006, what is the difference between the Unemployed and educated labor force (% of population) of OECD members and Unemployed and educated labor force (% of population) of Brazil?
Make the answer very short. 19.44. In the year 2006, what is the difference between the Unemployed and educated labor force (% of population) in OECD members and Unemployed and educated labor force (% of population) in Bulgaria?
Ensure brevity in your answer.  12.34. In the year 2006, what is the difference between the Unemployed and educated labor force (% of population) in OECD members and Unemployed and educated labor force (% of population) in United Kingdom?
Make the answer very short. 7.34. In the year 2006, what is the difference between the Unemployed and educated labor force (% of population) in Brazil and Unemployed and educated labor force (% of population) in United Kingdom?
Your answer should be compact. -12.1. In the year 2006, what is the difference between the Unemployed and educated labor force (% of population) in Bulgaria and Unemployed and educated labor force (% of population) in United Kingdom?
Your answer should be compact. -5. In the year 2007, what is the difference between the Unemployed and educated labor force (% of population) in OECD members and Unemployed and educated labor force (% of population) in Brazil?
Ensure brevity in your answer.  19.96. In the year 2007, what is the difference between the Unemployed and educated labor force (% of population) in OECD members and Unemployed and educated labor force (% of population) in Bulgaria?
Make the answer very short. 15.46. In the year 2007, what is the difference between the Unemployed and educated labor force (% of population) in OECD members and Unemployed and educated labor force (% of population) in United Kingdom?
Make the answer very short. 8.86. In the year 2007, what is the difference between the Unemployed and educated labor force (% of population) of Bulgaria and Unemployed and educated labor force (% of population) of United Kingdom?
Provide a succinct answer. -6.6. In the year 2011, what is the difference between the Unemployed and educated labor force (% of population) in OECD members and Unemployed and educated labor force (% of population) in Brazil?
Offer a terse response. 5.76. In the year 2011, what is the difference between the Unemployed and educated labor force (% of population) of OECD members and Unemployed and educated labor force (% of population) of Bulgaria?
Your answer should be very brief. 5.86. In the year 2011, what is the difference between the Unemployed and educated labor force (% of population) in OECD members and Unemployed and educated labor force (% of population) in United Kingdom?
Ensure brevity in your answer.  -1.84. In the year 2011, what is the difference between the Unemployed and educated labor force (% of population) in Brazil and Unemployed and educated labor force (% of population) in United Kingdom?
Keep it short and to the point. -7.6. In the year 2011, what is the difference between the Unemployed and educated labor force (% of population) of Bulgaria and Unemployed and educated labor force (% of population) of United Kingdom?
Your answer should be compact. -7.7. What is the ratio of the Unemployed and educated labor force (% of population) in OECD members in 2001 to that in 2002?
Provide a short and direct response. 0.9. What is the ratio of the Unemployed and educated labor force (% of population) of OECD members in 2001 to that in 2003?
Your response must be concise. 0.87. What is the ratio of the Unemployed and educated labor force (% of population) of Brazil in 2001 to that in 2003?
Provide a succinct answer. 0.87. What is the ratio of the Unemployed and educated labor force (% of population) in Bulgaria in 2001 to that in 2003?
Your answer should be compact. 0.89. What is the ratio of the Unemployed and educated labor force (% of population) in United Kingdom in 2001 to that in 2003?
Provide a succinct answer. 0.86. What is the ratio of the Unemployed and educated labor force (% of population) in OECD members in 2001 to that in 2004?
Keep it short and to the point. 0.88. What is the ratio of the Unemployed and educated labor force (% of population) of Brazil in 2001 to that in 2004?
Keep it short and to the point. 0.87. What is the ratio of the Unemployed and educated labor force (% of population) in Bulgaria in 2001 to that in 2004?
Ensure brevity in your answer.  0.9. What is the ratio of the Unemployed and educated labor force (% of population) in United Kingdom in 2001 to that in 2004?
Offer a very short reply. 0.84. What is the ratio of the Unemployed and educated labor force (% of population) in OECD members in 2001 to that in 2005?
Give a very brief answer. 0.89. What is the ratio of the Unemployed and educated labor force (% of population) in Brazil in 2001 to that in 2005?
Provide a short and direct response. 0.81. What is the ratio of the Unemployed and educated labor force (% of population) in United Kingdom in 2001 to that in 2005?
Provide a short and direct response. 0.79. What is the ratio of the Unemployed and educated labor force (% of population) of OECD members in 2001 to that in 2006?
Provide a short and direct response. 0.88. What is the ratio of the Unemployed and educated labor force (% of population) in Brazil in 2001 to that in 2006?
Provide a short and direct response. 0.72. What is the ratio of the Unemployed and educated labor force (% of population) of Bulgaria in 2001 to that in 2006?
Your answer should be very brief. 0.96. What is the ratio of the Unemployed and educated labor force (% of population) of United Kingdom in 2001 to that in 2006?
Your answer should be compact. 0.8. What is the ratio of the Unemployed and educated labor force (% of population) in OECD members in 2001 to that in 2007?
Provide a succinct answer. 0.84. What is the ratio of the Unemployed and educated labor force (% of population) of Brazil in 2001 to that in 2007?
Your response must be concise. 0.63. What is the ratio of the Unemployed and educated labor force (% of population) of Bulgaria in 2001 to that in 2007?
Provide a succinct answer. 1.2. What is the ratio of the Unemployed and educated labor force (% of population) of United Kingdom in 2001 to that in 2007?
Ensure brevity in your answer.  0.83. What is the ratio of the Unemployed and educated labor force (% of population) in OECD members in 2001 to that in 2011?
Your answer should be very brief. 1.14. What is the ratio of the Unemployed and educated labor force (% of population) of Brazil in 2001 to that in 2011?
Ensure brevity in your answer.  0.22. What is the ratio of the Unemployed and educated labor force (% of population) of Bulgaria in 2001 to that in 2011?
Your answer should be compact. 0.87. What is the ratio of the Unemployed and educated labor force (% of population) in United Kingdom in 2001 to that in 2011?
Your answer should be compact. 0.64. What is the ratio of the Unemployed and educated labor force (% of population) in OECD members in 2002 to that in 2003?
Give a very brief answer. 0.96. What is the ratio of the Unemployed and educated labor force (% of population) of Brazil in 2002 to that in 2003?
Give a very brief answer. 0.9. What is the ratio of the Unemployed and educated labor force (% of population) of Bulgaria in 2002 to that in 2003?
Offer a very short reply. 0.9. What is the ratio of the Unemployed and educated labor force (% of population) of United Kingdom in 2002 to that in 2003?
Ensure brevity in your answer.  0.96. What is the ratio of the Unemployed and educated labor force (% of population) of OECD members in 2002 to that in 2004?
Make the answer very short. 0.97. What is the ratio of the Unemployed and educated labor force (% of population) of Bulgaria in 2002 to that in 2004?
Make the answer very short. 0.91. What is the ratio of the Unemployed and educated labor force (% of population) of Brazil in 2002 to that in 2005?
Offer a very short reply. 0.84. What is the ratio of the Unemployed and educated labor force (% of population) of Bulgaria in 2002 to that in 2005?
Provide a short and direct response. 1.01. What is the ratio of the Unemployed and educated labor force (% of population) of OECD members in 2002 to that in 2006?
Give a very brief answer. 0.98. What is the ratio of the Unemployed and educated labor force (% of population) of Brazil in 2002 to that in 2006?
Ensure brevity in your answer.  0.75. What is the ratio of the Unemployed and educated labor force (% of population) in Bulgaria in 2002 to that in 2006?
Your answer should be compact. 0.97. What is the ratio of the Unemployed and educated labor force (% of population) of United Kingdom in 2002 to that in 2006?
Your answer should be very brief. 0.89. What is the ratio of the Unemployed and educated labor force (% of population) in OECD members in 2002 to that in 2007?
Provide a succinct answer. 0.94. What is the ratio of the Unemployed and educated labor force (% of population) of Brazil in 2002 to that in 2007?
Provide a succinct answer. 0.66. What is the ratio of the Unemployed and educated labor force (% of population) in Bulgaria in 2002 to that in 2007?
Your answer should be compact. 1.21. What is the ratio of the Unemployed and educated labor force (% of population) in United Kingdom in 2002 to that in 2007?
Keep it short and to the point. 0.92. What is the ratio of the Unemployed and educated labor force (% of population) of OECD members in 2002 to that in 2011?
Offer a terse response. 1.27. What is the ratio of the Unemployed and educated labor force (% of population) of Brazil in 2002 to that in 2011?
Your response must be concise. 0.23. What is the ratio of the Unemployed and educated labor force (% of population) in Bulgaria in 2002 to that in 2011?
Ensure brevity in your answer.  0.87. What is the ratio of the Unemployed and educated labor force (% of population) of United Kingdom in 2002 to that in 2011?
Your answer should be compact. 0.71. What is the ratio of the Unemployed and educated labor force (% of population) in OECD members in 2003 to that in 2004?
Your response must be concise. 1.01. What is the ratio of the Unemployed and educated labor force (% of population) in Brazil in 2003 to that in 2004?
Your answer should be compact. 1. What is the ratio of the Unemployed and educated labor force (% of population) of Bulgaria in 2003 to that in 2004?
Your answer should be very brief. 1.02. What is the ratio of the Unemployed and educated labor force (% of population) in United Kingdom in 2003 to that in 2004?
Make the answer very short. 0.97. What is the ratio of the Unemployed and educated labor force (% of population) in OECD members in 2003 to that in 2005?
Offer a terse response. 1.02. What is the ratio of the Unemployed and educated labor force (% of population) in Bulgaria in 2003 to that in 2005?
Provide a succinct answer. 1.13. What is the ratio of the Unemployed and educated labor force (% of population) in United Kingdom in 2003 to that in 2005?
Provide a succinct answer. 0.91. What is the ratio of the Unemployed and educated labor force (% of population) in OECD members in 2003 to that in 2006?
Give a very brief answer. 1.02. What is the ratio of the Unemployed and educated labor force (% of population) in Bulgaria in 2003 to that in 2006?
Provide a succinct answer. 1.08. What is the ratio of the Unemployed and educated labor force (% of population) of United Kingdom in 2003 to that in 2006?
Make the answer very short. 0.93. What is the ratio of the Unemployed and educated labor force (% of population) in OECD members in 2003 to that in 2007?
Provide a succinct answer. 0.97. What is the ratio of the Unemployed and educated labor force (% of population) of Brazil in 2003 to that in 2007?
Provide a short and direct response. 0.73. What is the ratio of the Unemployed and educated labor force (% of population) in Bulgaria in 2003 to that in 2007?
Your response must be concise. 1.35. What is the ratio of the Unemployed and educated labor force (% of population) of United Kingdom in 2003 to that in 2007?
Offer a terse response. 0.96. What is the ratio of the Unemployed and educated labor force (% of population) of OECD members in 2003 to that in 2011?
Offer a very short reply. 1.32. What is the ratio of the Unemployed and educated labor force (% of population) in Brazil in 2003 to that in 2011?
Offer a very short reply. 0.25. What is the ratio of the Unemployed and educated labor force (% of population) in Bulgaria in 2003 to that in 2011?
Provide a succinct answer. 0.97. What is the ratio of the Unemployed and educated labor force (% of population) of United Kingdom in 2003 to that in 2011?
Make the answer very short. 0.74. What is the ratio of the Unemployed and educated labor force (% of population) of OECD members in 2004 to that in 2005?
Ensure brevity in your answer.  1.01. What is the ratio of the Unemployed and educated labor force (% of population) in Brazil in 2004 to that in 2005?
Offer a very short reply. 0.94. What is the ratio of the Unemployed and educated labor force (% of population) of Bulgaria in 2004 to that in 2005?
Give a very brief answer. 1.11. What is the ratio of the Unemployed and educated labor force (% of population) of United Kingdom in 2004 to that in 2005?
Give a very brief answer. 0.94. What is the ratio of the Unemployed and educated labor force (% of population) in OECD members in 2004 to that in 2006?
Your response must be concise. 1. What is the ratio of the Unemployed and educated labor force (% of population) of Bulgaria in 2004 to that in 2006?
Provide a succinct answer. 1.07. What is the ratio of the Unemployed and educated labor force (% of population) of United Kingdom in 2004 to that in 2006?
Give a very brief answer. 0.96. What is the ratio of the Unemployed and educated labor force (% of population) in OECD members in 2004 to that in 2007?
Make the answer very short. 0.96. What is the ratio of the Unemployed and educated labor force (% of population) of Brazil in 2004 to that in 2007?
Your answer should be very brief. 0.73. What is the ratio of the Unemployed and educated labor force (% of population) in Bulgaria in 2004 to that in 2007?
Offer a terse response. 1.33. What is the ratio of the Unemployed and educated labor force (% of population) in OECD members in 2004 to that in 2011?
Offer a very short reply. 1.3. What is the ratio of the Unemployed and educated labor force (% of population) in Bulgaria in 2004 to that in 2011?
Keep it short and to the point. 0.96. What is the ratio of the Unemployed and educated labor force (% of population) of United Kingdom in 2004 to that in 2011?
Offer a terse response. 0.77. What is the ratio of the Unemployed and educated labor force (% of population) in OECD members in 2005 to that in 2006?
Your answer should be compact. 0.99. What is the ratio of the Unemployed and educated labor force (% of population) of Brazil in 2005 to that in 2006?
Offer a terse response. 0.89. What is the ratio of the Unemployed and educated labor force (% of population) in Bulgaria in 2005 to that in 2006?
Provide a succinct answer. 0.96. What is the ratio of the Unemployed and educated labor force (% of population) of United Kingdom in 2005 to that in 2006?
Your answer should be compact. 1.02. What is the ratio of the Unemployed and educated labor force (% of population) in OECD members in 2005 to that in 2007?
Provide a succinct answer. 0.95. What is the ratio of the Unemployed and educated labor force (% of population) of Brazil in 2005 to that in 2007?
Offer a terse response. 0.78. What is the ratio of the Unemployed and educated labor force (% of population) of Bulgaria in 2005 to that in 2007?
Offer a terse response. 1.2. What is the ratio of the Unemployed and educated labor force (% of population) in United Kingdom in 2005 to that in 2007?
Your answer should be very brief. 1.05. What is the ratio of the Unemployed and educated labor force (% of population) of OECD members in 2005 to that in 2011?
Provide a succinct answer. 1.29. What is the ratio of the Unemployed and educated labor force (% of population) in Brazil in 2005 to that in 2011?
Provide a short and direct response. 0.27. What is the ratio of the Unemployed and educated labor force (% of population) of Bulgaria in 2005 to that in 2011?
Keep it short and to the point. 0.87. What is the ratio of the Unemployed and educated labor force (% of population) of United Kingdom in 2005 to that in 2011?
Keep it short and to the point. 0.82. What is the ratio of the Unemployed and educated labor force (% of population) of OECD members in 2006 to that in 2007?
Your answer should be very brief. 0.96. What is the ratio of the Unemployed and educated labor force (% of population) in Brazil in 2006 to that in 2007?
Provide a short and direct response. 0.88. What is the ratio of the Unemployed and educated labor force (% of population) in Bulgaria in 2006 to that in 2007?
Give a very brief answer. 1.24. What is the ratio of the Unemployed and educated labor force (% of population) in United Kingdom in 2006 to that in 2007?
Give a very brief answer. 1.03. What is the ratio of the Unemployed and educated labor force (% of population) of OECD members in 2006 to that in 2011?
Make the answer very short. 1.3. What is the ratio of the Unemployed and educated labor force (% of population) of Bulgaria in 2006 to that in 2011?
Your answer should be compact. 0.9. What is the ratio of the Unemployed and educated labor force (% of population) in United Kingdom in 2006 to that in 2011?
Offer a very short reply. 0.8. What is the ratio of the Unemployed and educated labor force (% of population) in OECD members in 2007 to that in 2011?
Ensure brevity in your answer.  1.35. What is the ratio of the Unemployed and educated labor force (% of population) in Brazil in 2007 to that in 2011?
Provide a succinct answer. 0.34. What is the ratio of the Unemployed and educated labor force (% of population) of Bulgaria in 2007 to that in 2011?
Offer a very short reply. 0.72. What is the ratio of the Unemployed and educated labor force (% of population) of United Kingdom in 2007 to that in 2011?
Your answer should be very brief. 0.78. What is the difference between the highest and the second highest Unemployed and educated labor force (% of population) of OECD members?
Your response must be concise. 0.66. What is the difference between the highest and the lowest Unemployed and educated labor force (% of population) in OECD members?
Keep it short and to the point. 6.3. What is the difference between the highest and the lowest Unemployed and educated labor force (% of population) in Brazil?
Ensure brevity in your answer.  9.4. 